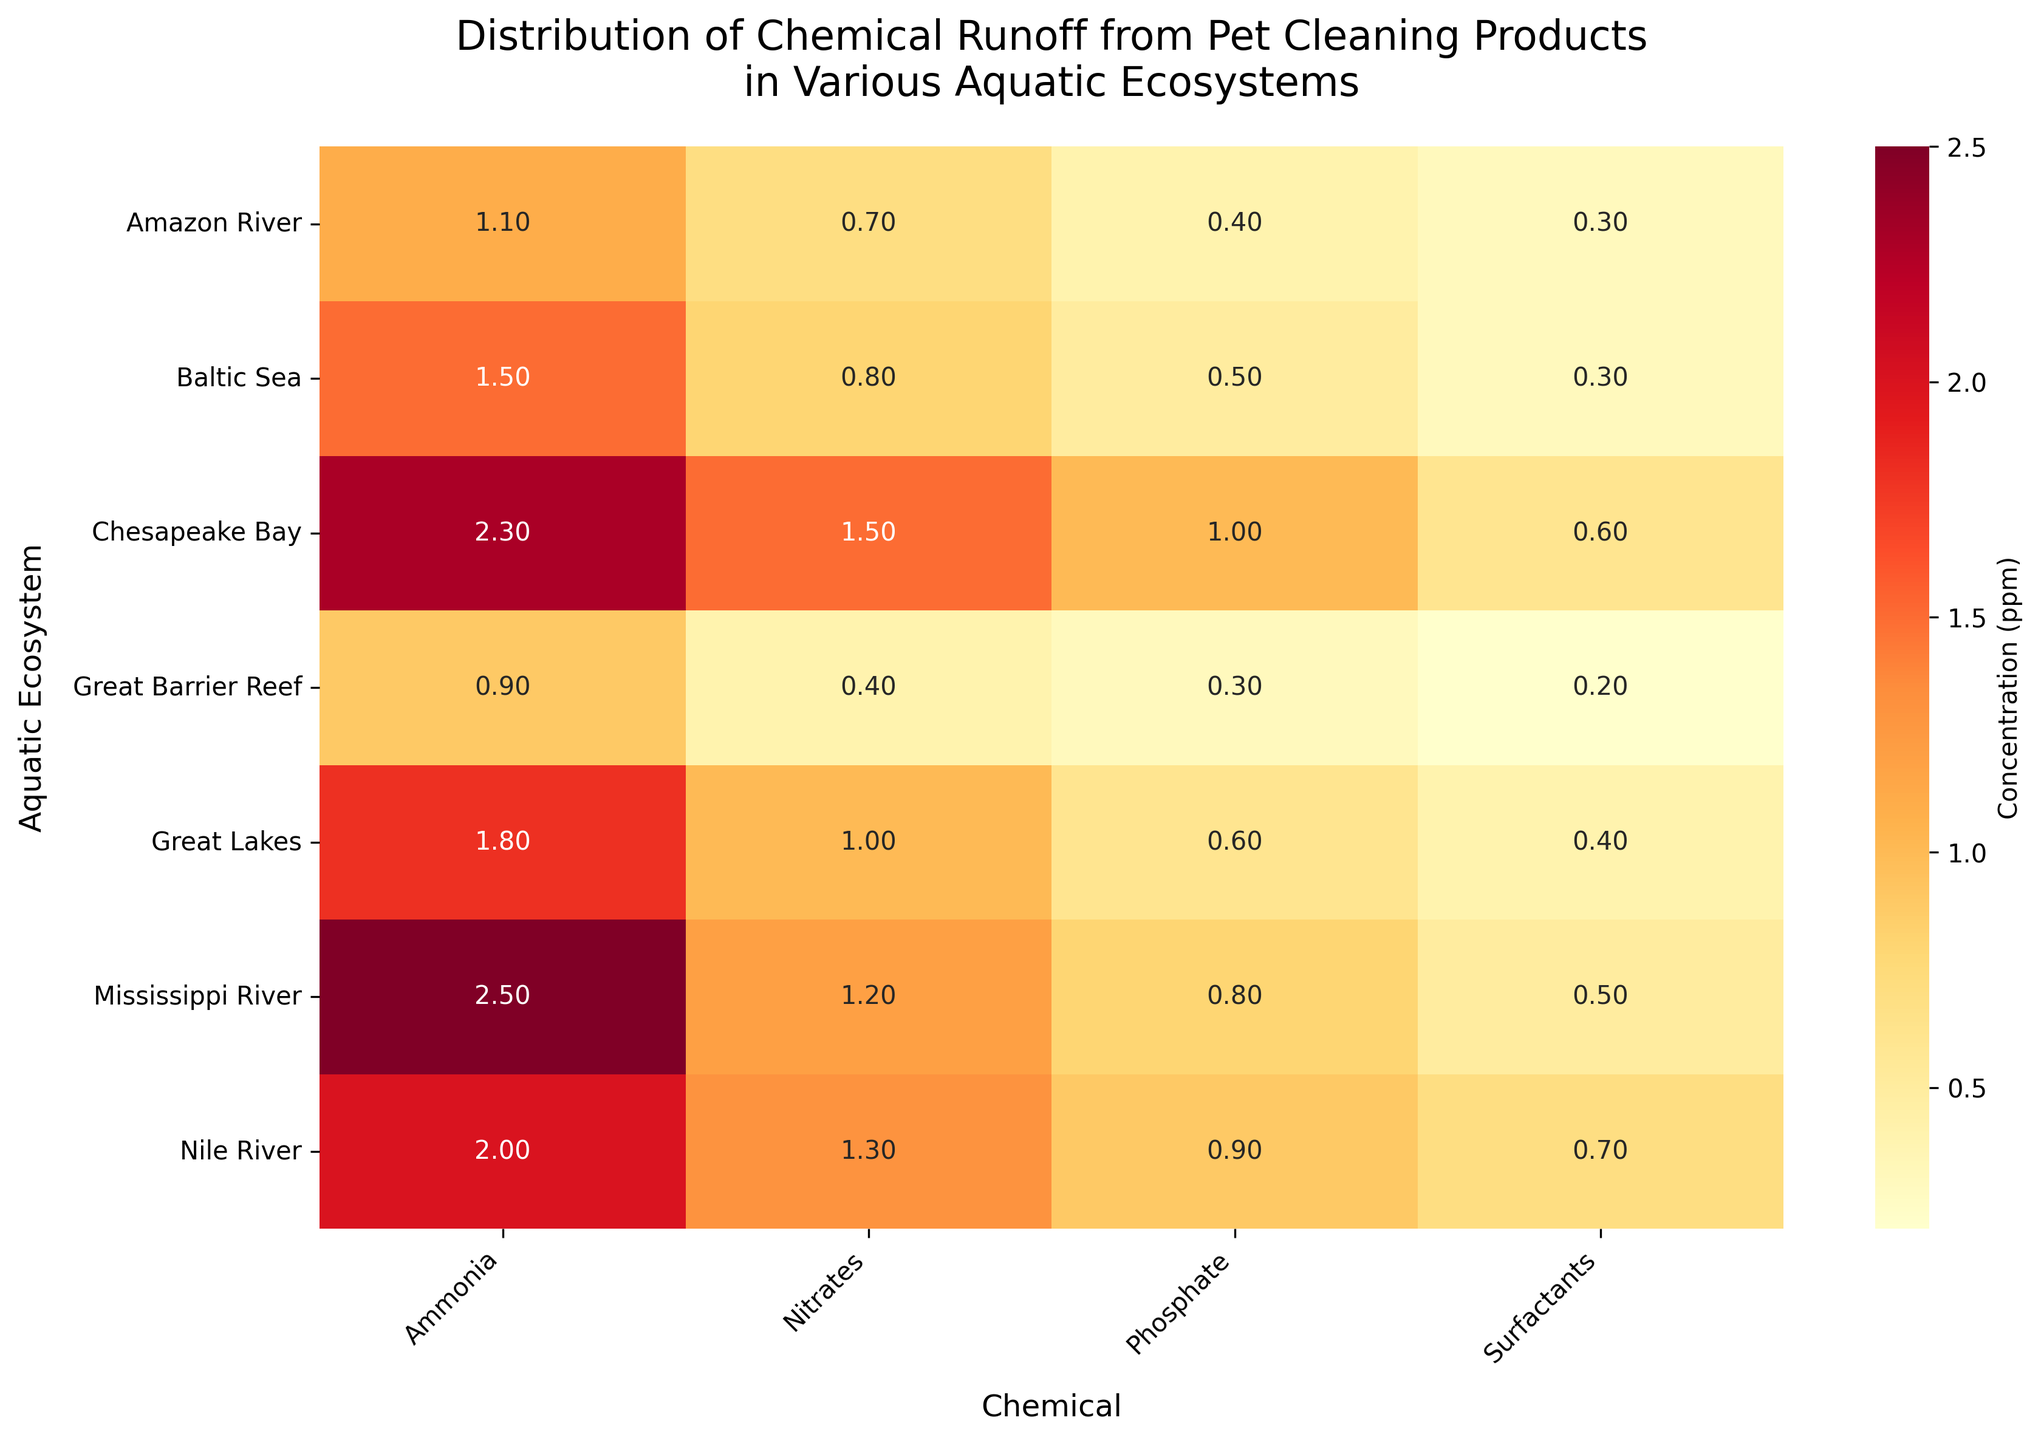What is the title of the heatmap? The title is located at the top of the heatmap, and it describes what the visual is about.
Answer: Distribution of Chemical Runoff from Pet Cleaning Products in Various Aquatic Ecosystems Which aquatic ecosystem has the highest concentration of ammonia? To find the highest concentration of ammonia, look at the column for "Ammonia" and identify the highest value and its corresponding row.
Answer: Mississippi River What is the average concentration of nitrates across all aquatic ecosystems? Sum the concentrations of nitrates in all ecosystems and divide by the number of ecosystems (6). Calculation: (1.2 + 0.7 + 0.4 + 1.0 + 1.3 + 0.8 + 1.5)/6 = 0.975
Answer: 0.975 ppm Compare the concentrations of phosphates in the Nile River and the Amazon River. Which is higher? Look at the "Phosphate" values for the Nile River and Amazon River. Subtract the Amazon's value from the Nile's value.
Answer: Nile River (0.9 ppm) is higher than Amazon River (0.4 ppm) Which chemical has the most uniform distribution across the aquatic ecosystems? Check the variation in each chemical's concentration values across different ecosystems. The one with the least variation is the most uniform.
Answer: Surfactants Are there any ecosystems where the concentration of surfactants is equal to 0.5 ppm or higher? If so, which ones? Identify the "Surfactants" column and find any values that are 0.5 ppm or higher.
Answer: Mississippi River and Nile River Calculate the total concentration of all chemicals in the Chesapeake Bay. Add up the concentrations of Ammonia, Nitrates, Phosphates, and Surfactants for the Chesapeake Bay. Calculation: 2.3 + 1.5 + 1.0 + 0.6 = 5.4
Answer: 5.4 ppm Is the concentration of ammonia in the Great Barrier Reef higher or lower than in the Great Lakes? Compare the ammonia concentration values of the Great Barrier Reef and Great Lakes.
Answer: Lower (0.9 ppm in Great Barrier Reef vs. 1.8 ppm in Great Lakes) Which aquatic ecosystem has the lowest concentration of surfactants? Look at the "Surfactants" column and identify the lowest value and its corresponding row.
Answer: Great Barrier Reef What is the difference between the highest and lowest concentrations of nitrates across all ecosystems? Identify the highest and lowest nitrate values, then subtract the lowest from the highest. Highest: 1.5 (Chesapeake Bay), Lowest: 0.4 (Great Barrier Reef). Difference = 1.5 - 0.4 = 1.1
Answer: 1.1 ppm 